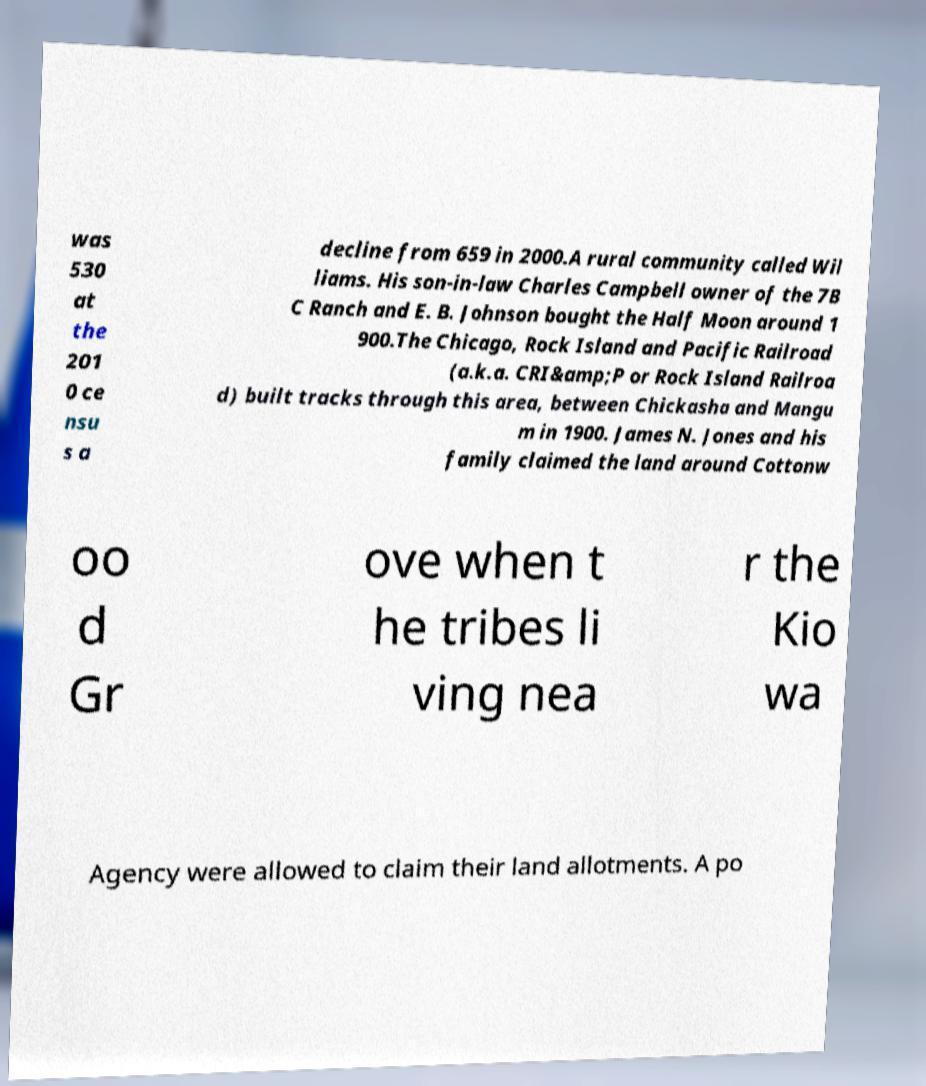Could you extract and type out the text from this image? was 530 at the 201 0 ce nsu s a decline from 659 in 2000.A rural community called Wil liams. His son-in-law Charles Campbell owner of the 7B C Ranch and E. B. Johnson bought the Half Moon around 1 900.The Chicago, Rock Island and Pacific Railroad (a.k.a. CRI&amp;P or Rock Island Railroa d) built tracks through this area, between Chickasha and Mangu m in 1900. James N. Jones and his family claimed the land around Cottonw oo d Gr ove when t he tribes li ving nea r the Kio wa Agency were allowed to claim their land allotments. A po 